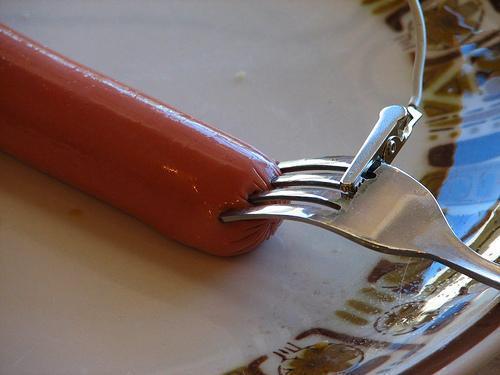How many people have yellow shoes?
Give a very brief answer. 0. 